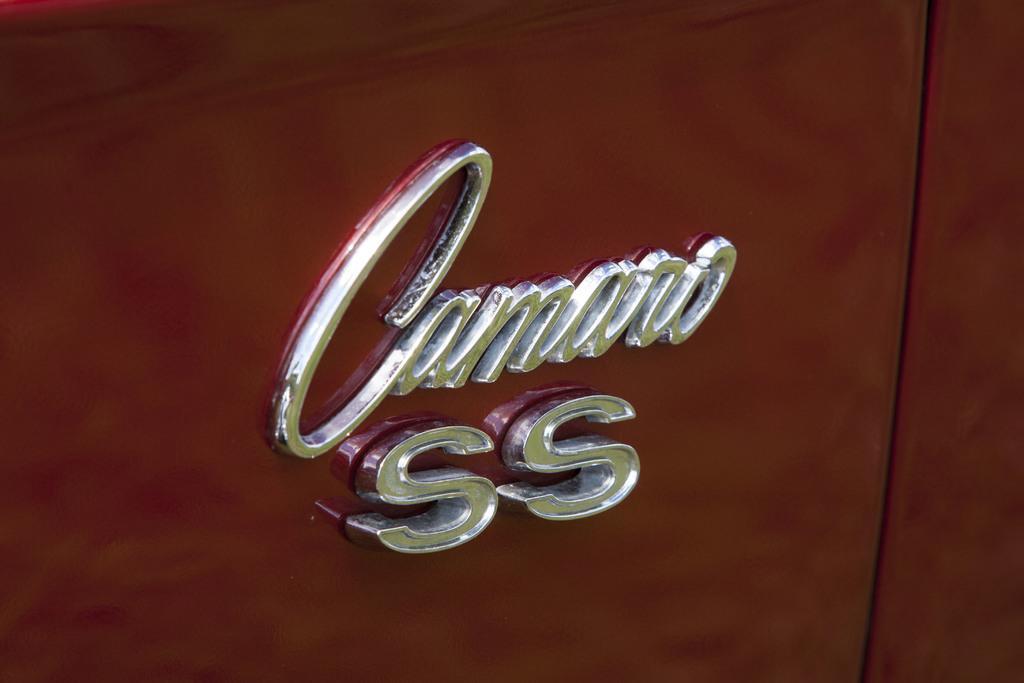Describe this image in one or two sentences. In the middle of this image, there are silver color letters on the surface of an object. And the background is brown in color. 